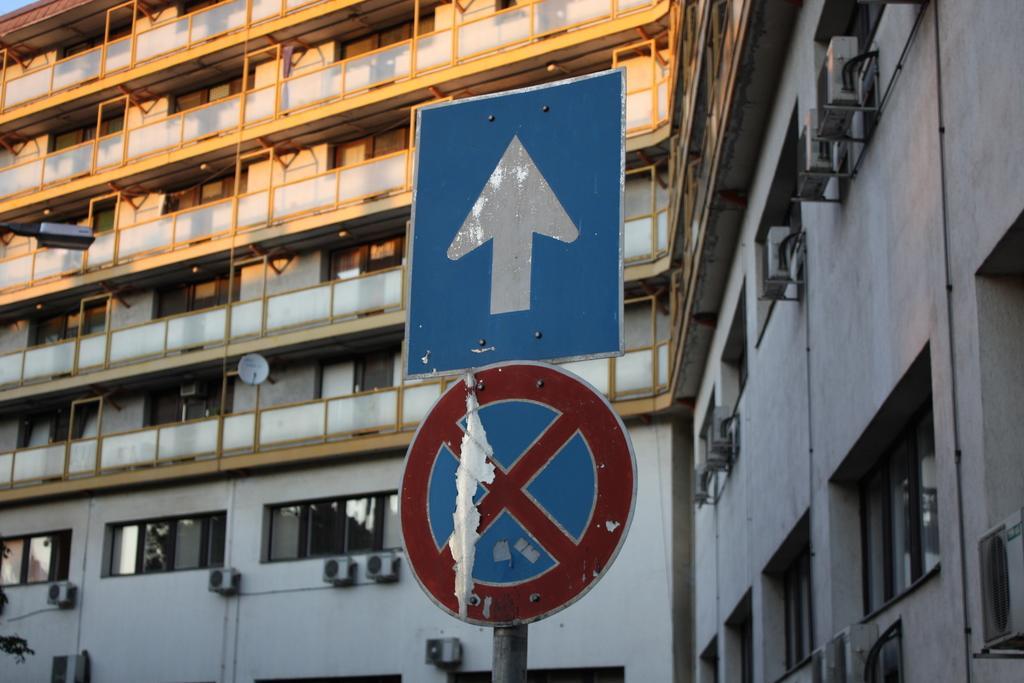In one or two sentences, can you explain what this image depicts? In this image I can see few sign boards, a street light and in background I can see building, number of windows and over here I can see an antenna. 